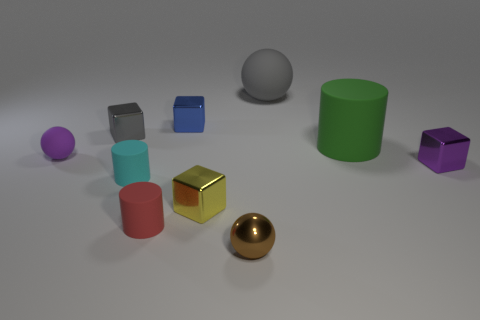Subtract all spheres. How many objects are left? 7 Subtract all rubber cylinders. Subtract all tiny red shiny balls. How many objects are left? 7 Add 3 big gray matte things. How many big gray matte things are left? 4 Add 2 large matte things. How many large matte things exist? 4 Subtract 1 brown spheres. How many objects are left? 9 